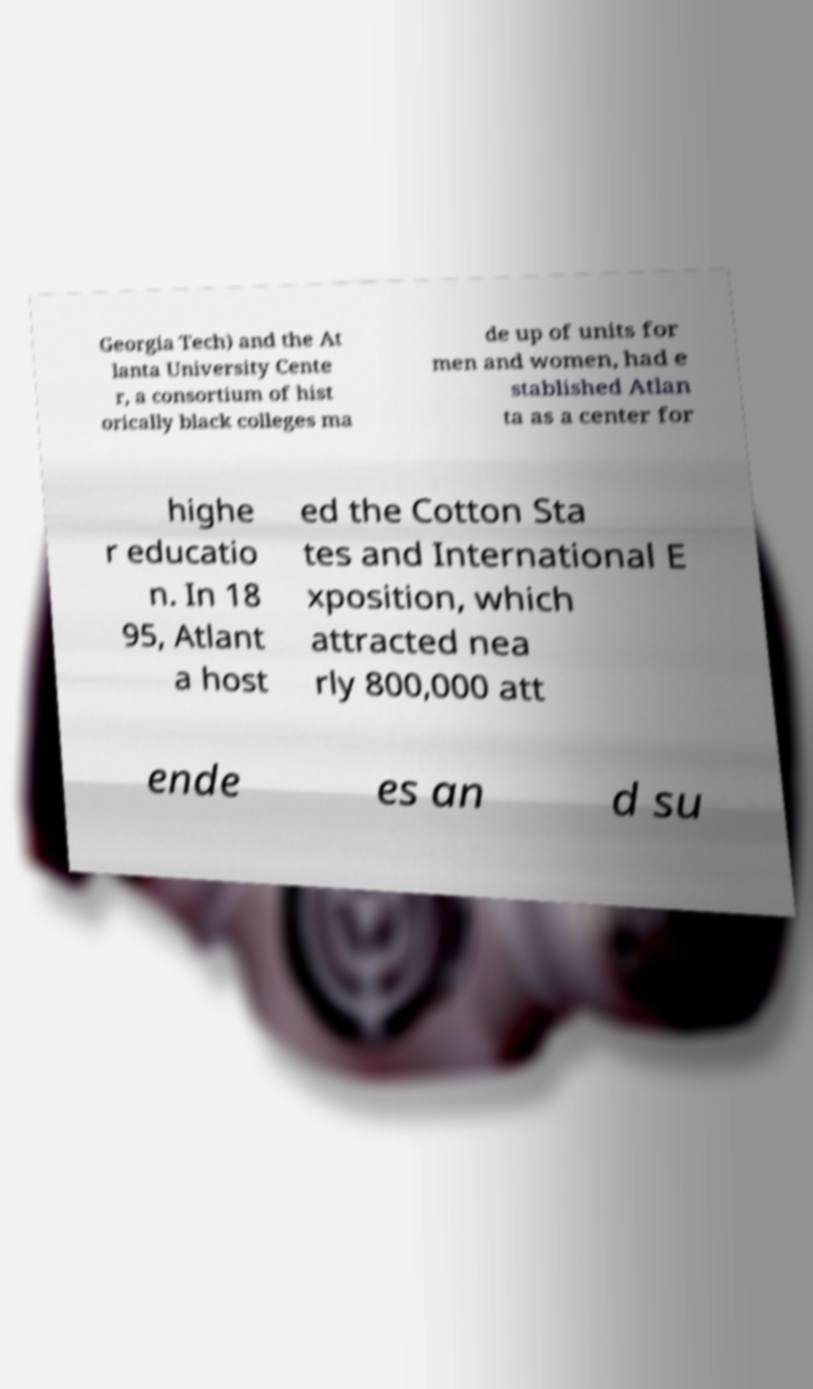For documentation purposes, I need the text within this image transcribed. Could you provide that? Georgia Tech) and the At lanta University Cente r, a consortium of hist orically black colleges ma de up of units for men and women, had e stablished Atlan ta as a center for highe r educatio n. In 18 95, Atlant a host ed the Cotton Sta tes and International E xposition, which attracted nea rly 800,000 att ende es an d su 